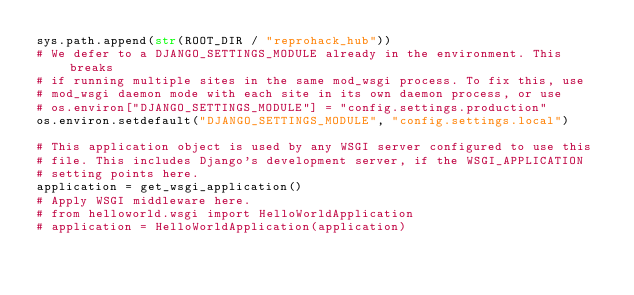<code> <loc_0><loc_0><loc_500><loc_500><_Python_>sys.path.append(str(ROOT_DIR / "reprohack_hub"))
# We defer to a DJANGO_SETTINGS_MODULE already in the environment. This breaks
# if running multiple sites in the same mod_wsgi process. To fix this, use
# mod_wsgi daemon mode with each site in its own daemon process, or use
# os.environ["DJANGO_SETTINGS_MODULE"] = "config.settings.production"
os.environ.setdefault("DJANGO_SETTINGS_MODULE", "config.settings.local")

# This application object is used by any WSGI server configured to use this
# file. This includes Django's development server, if the WSGI_APPLICATION
# setting points here.
application = get_wsgi_application()
# Apply WSGI middleware here.
# from helloworld.wsgi import HelloWorldApplication
# application = HelloWorldApplication(application)
</code> 